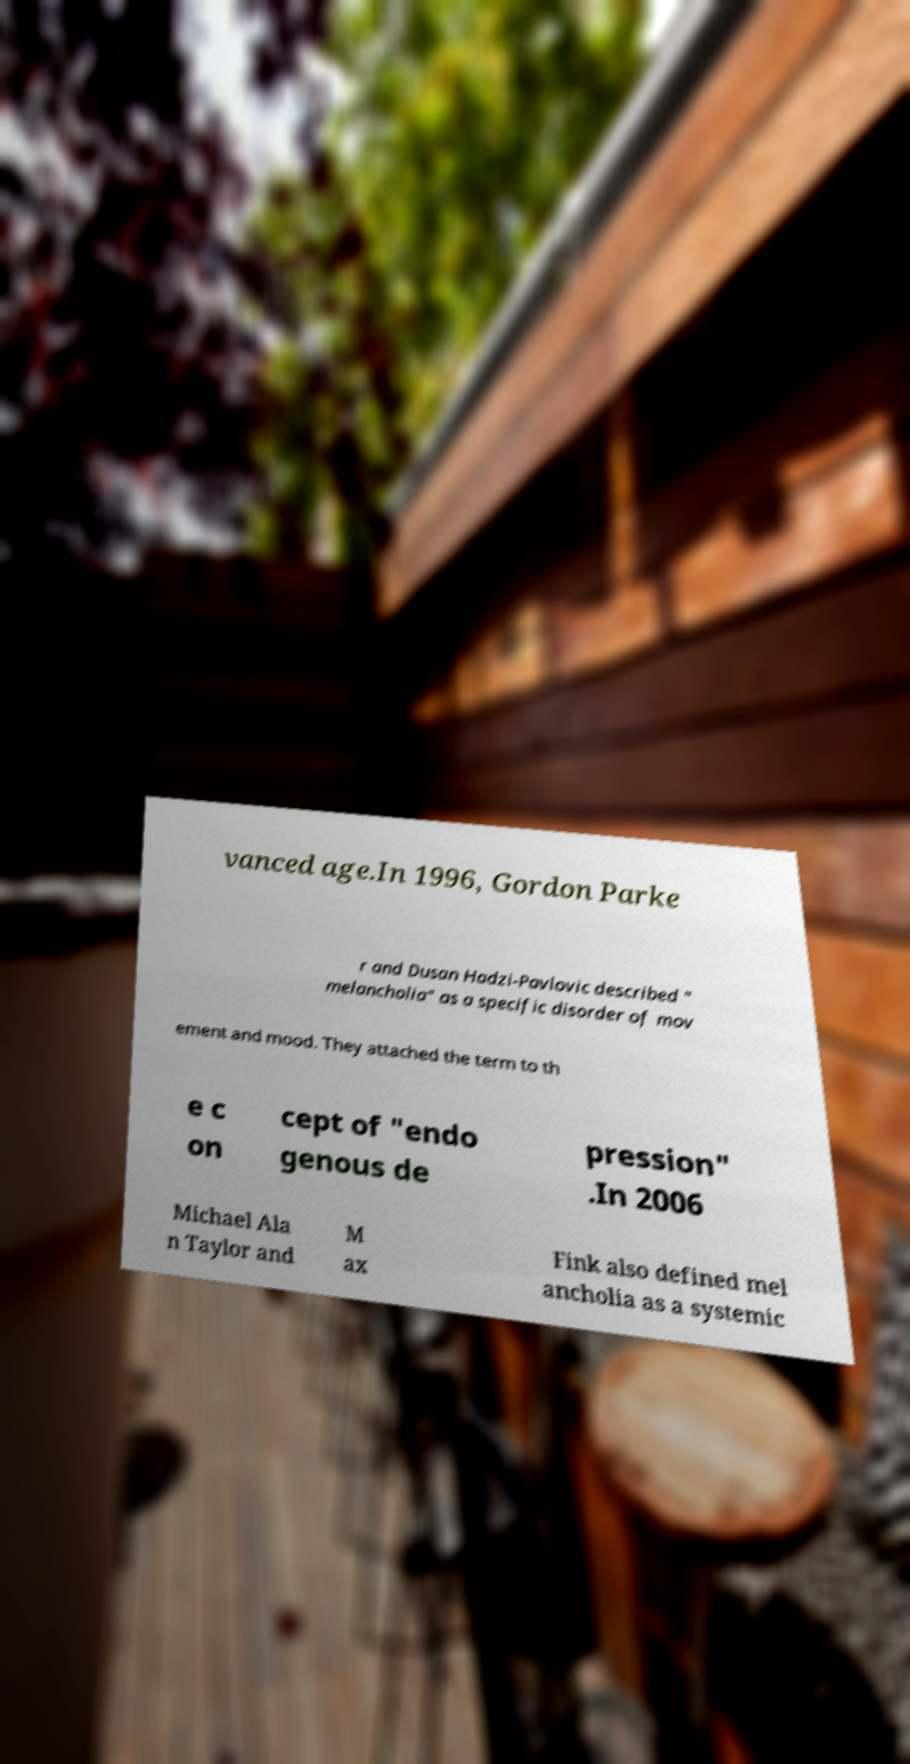There's text embedded in this image that I need extracted. Can you transcribe it verbatim? vanced age.In 1996, Gordon Parke r and Dusan Hadzi-Pavlovic described " melancholia" as a specific disorder of mov ement and mood. They attached the term to th e c on cept of "endo genous de pression" .In 2006 Michael Ala n Taylor and M ax Fink also defined mel ancholia as a systemic 